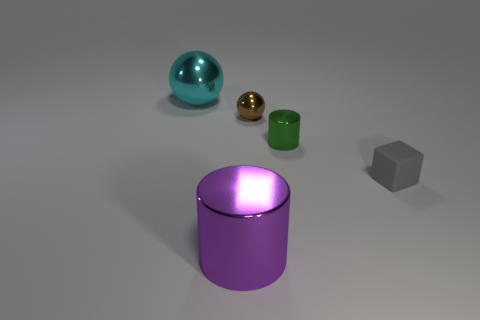Can you describe the atmosphere or theme conveyed by this arrangement of objects? The arrangement of objects portrays a minimalist and serene atmosphere. The composition allows for focus on the textures and materials of the objects, hinting at a study of shapes and light in space, characteristic of a modern, abstract aesthetic.  If these objects were part of a product advertisement, what do you think the advertisement might be for? If these objects were to be part of a product advertisement, it could be showcasing home decor elements, perhaps a range of designer furniture with emphasis on shapes and materials, or even an advertisement for a premium paint finish or material used in upscale interior designs. 